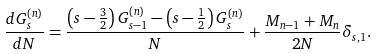Convert formula to latex. <formula><loc_0><loc_0><loc_500><loc_500>\frac { d G _ { s } ^ { ( n ) } } { d N } = \frac { \left ( s - \frac { 3 } { 2 } \right ) G _ { s - 1 } ^ { ( n ) } - \left ( s - \frac { 1 } { 2 } \right ) G _ { s } ^ { ( n ) } } { N } + \frac { M _ { n - 1 } + M _ { n } } { 2 N } \delta _ { s , 1 } .</formula> 